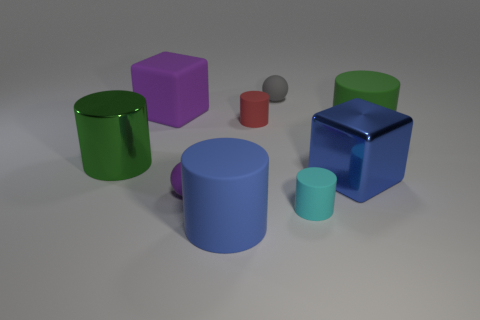What number of other things are the same color as the big metal cube?
Make the answer very short. 1. Is the large metallic cylinder the same color as the matte cube?
Provide a succinct answer. No. There is a matte thing left of the small ball that is in front of the gray sphere; what shape is it?
Your answer should be very brief. Cube. How many large cylinders are left of the large blue shiny block that is behind the tiny cyan rubber cylinder?
Give a very brief answer. 2. The tiny thing that is in front of the tiny gray rubber sphere and right of the red matte thing is made of what material?
Provide a short and direct response. Rubber. What shape is the purple object that is the same size as the green metallic object?
Offer a terse response. Cube. What color is the block that is in front of the green cylinder that is left of the large purple matte object to the right of the big metallic cylinder?
Ensure brevity in your answer.  Blue. How many objects are either tiny matte spheres that are behind the big green rubber cylinder or big green shiny things?
Your answer should be compact. 2. What is the material of the red cylinder that is the same size as the cyan thing?
Provide a short and direct response. Rubber. There is a large object on the left side of the purple rubber thing that is behind the large rubber object right of the small cyan matte cylinder; what is it made of?
Ensure brevity in your answer.  Metal. 